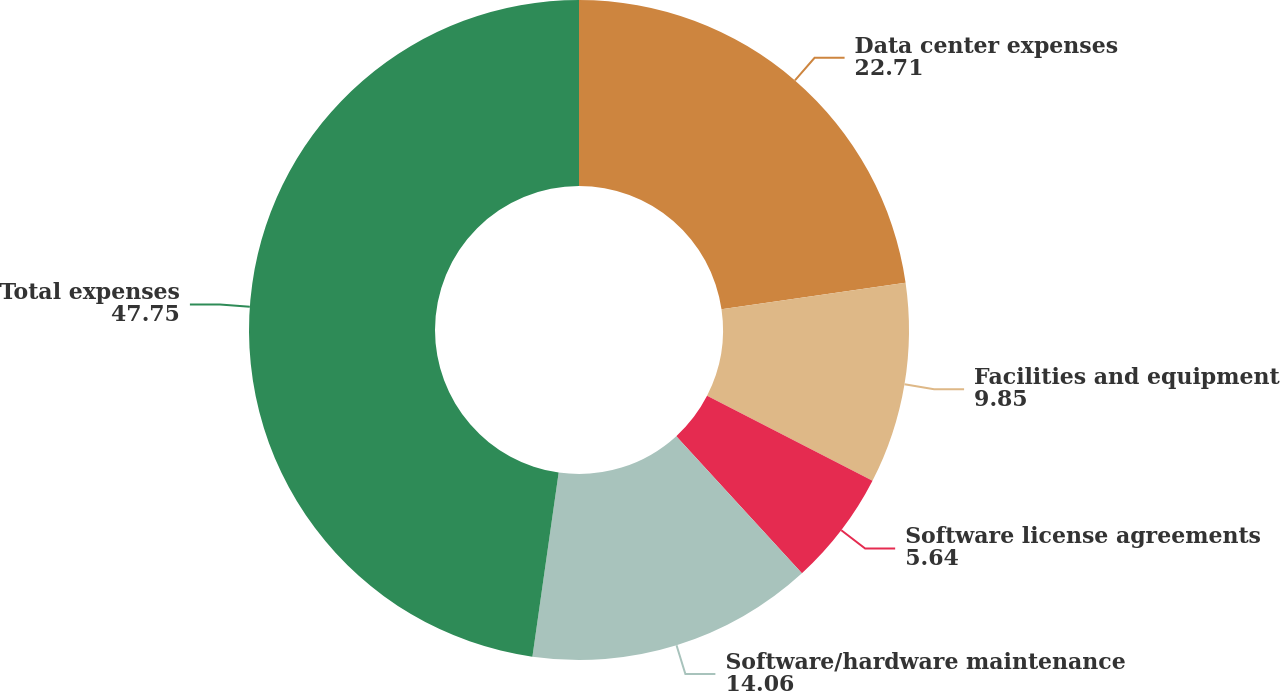<chart> <loc_0><loc_0><loc_500><loc_500><pie_chart><fcel>Data center expenses<fcel>Facilities and equipment<fcel>Software license agreements<fcel>Software/hardware maintenance<fcel>Total expenses<nl><fcel>22.71%<fcel>9.85%<fcel>5.64%<fcel>14.06%<fcel>47.75%<nl></chart> 